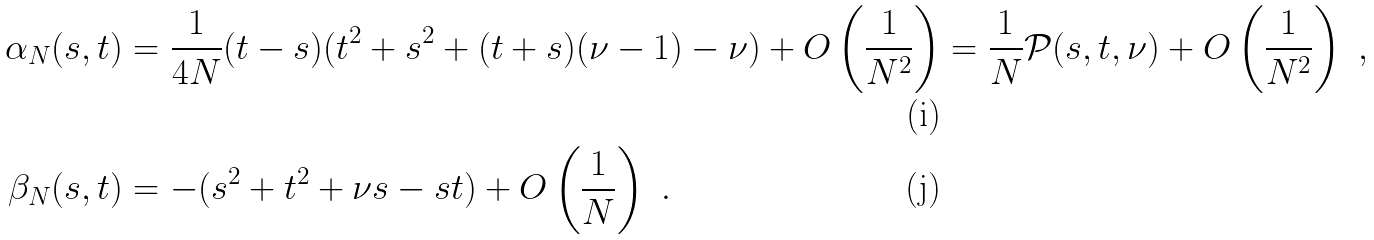Convert formula to latex. <formula><loc_0><loc_0><loc_500><loc_500>\alpha _ { N } ( s , t ) & = \frac { 1 } { 4 N } ( t - s ) ( t ^ { 2 } + s ^ { 2 } + ( t + s ) ( \nu - 1 ) - \nu ) + O \left ( \frac { 1 } { N ^ { 2 } } \right ) = \frac { 1 } { N } \mathcal { P } ( s , t , \nu ) + O \left ( \frac { 1 } { N ^ { 2 } } \right ) \ , \\ \beta _ { N } ( s , t ) & = - ( s ^ { 2 } + t ^ { 2 } + \nu s - s t ) + O \left ( \frac { 1 } { N } \right ) \ .</formula> 